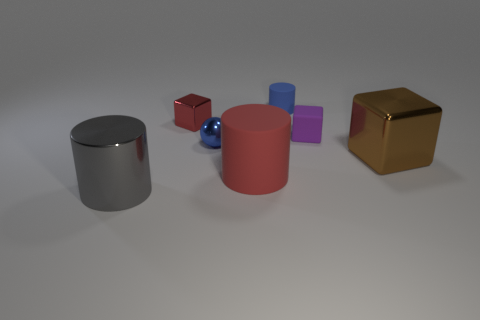Subtract all metallic cubes. How many cubes are left? 1 Add 1 large metal cylinders. How many objects exist? 8 Subtract all gray cylinders. How many cylinders are left? 2 Subtract all cubes. How many objects are left? 4 Add 7 cylinders. How many cylinders exist? 10 Subtract 0 cyan blocks. How many objects are left? 7 Subtract all gray cylinders. Subtract all blue spheres. How many cylinders are left? 2 Subtract all gray spheres. How many purple blocks are left? 1 Subtract all large gray cylinders. Subtract all tiny blue shiny balls. How many objects are left? 5 Add 4 small blue rubber objects. How many small blue rubber objects are left? 5 